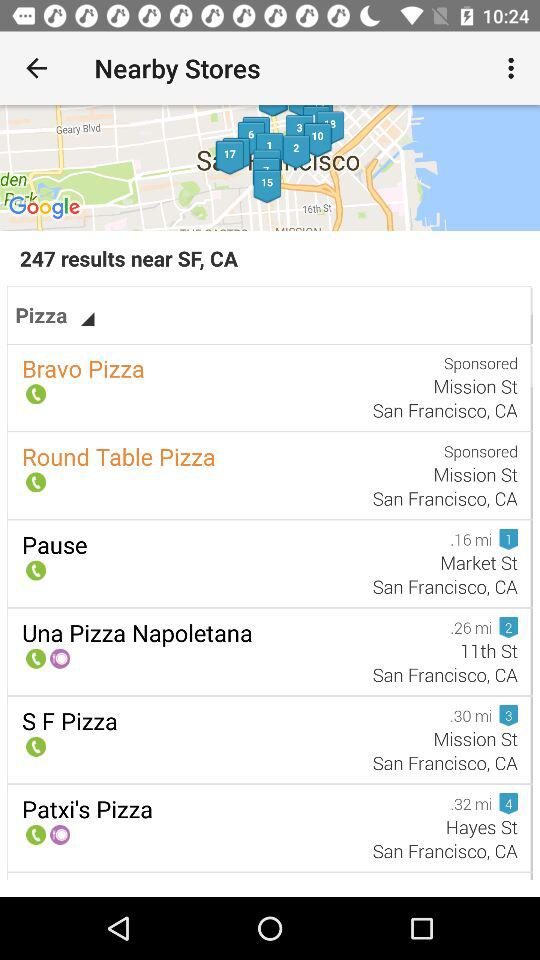How many pizza places in total are near SF,CA? There are 247 pizza places in total near SF,CA. 